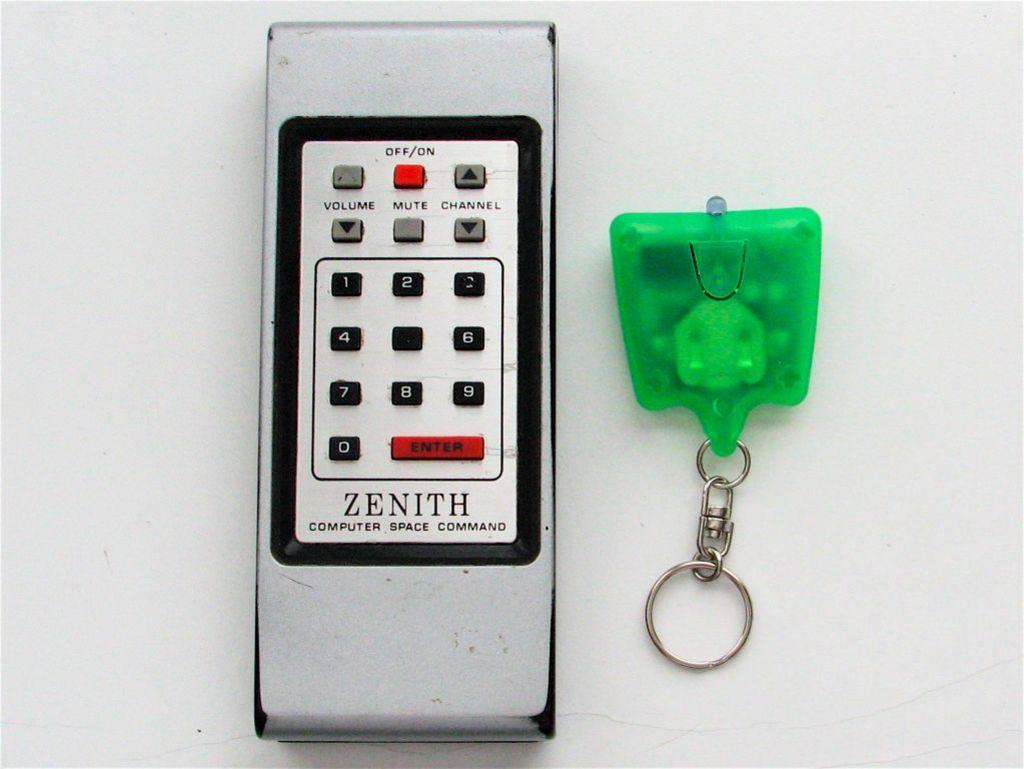<image>
Describe the image concisely. the word zenith is on a phone with a green item next to it 